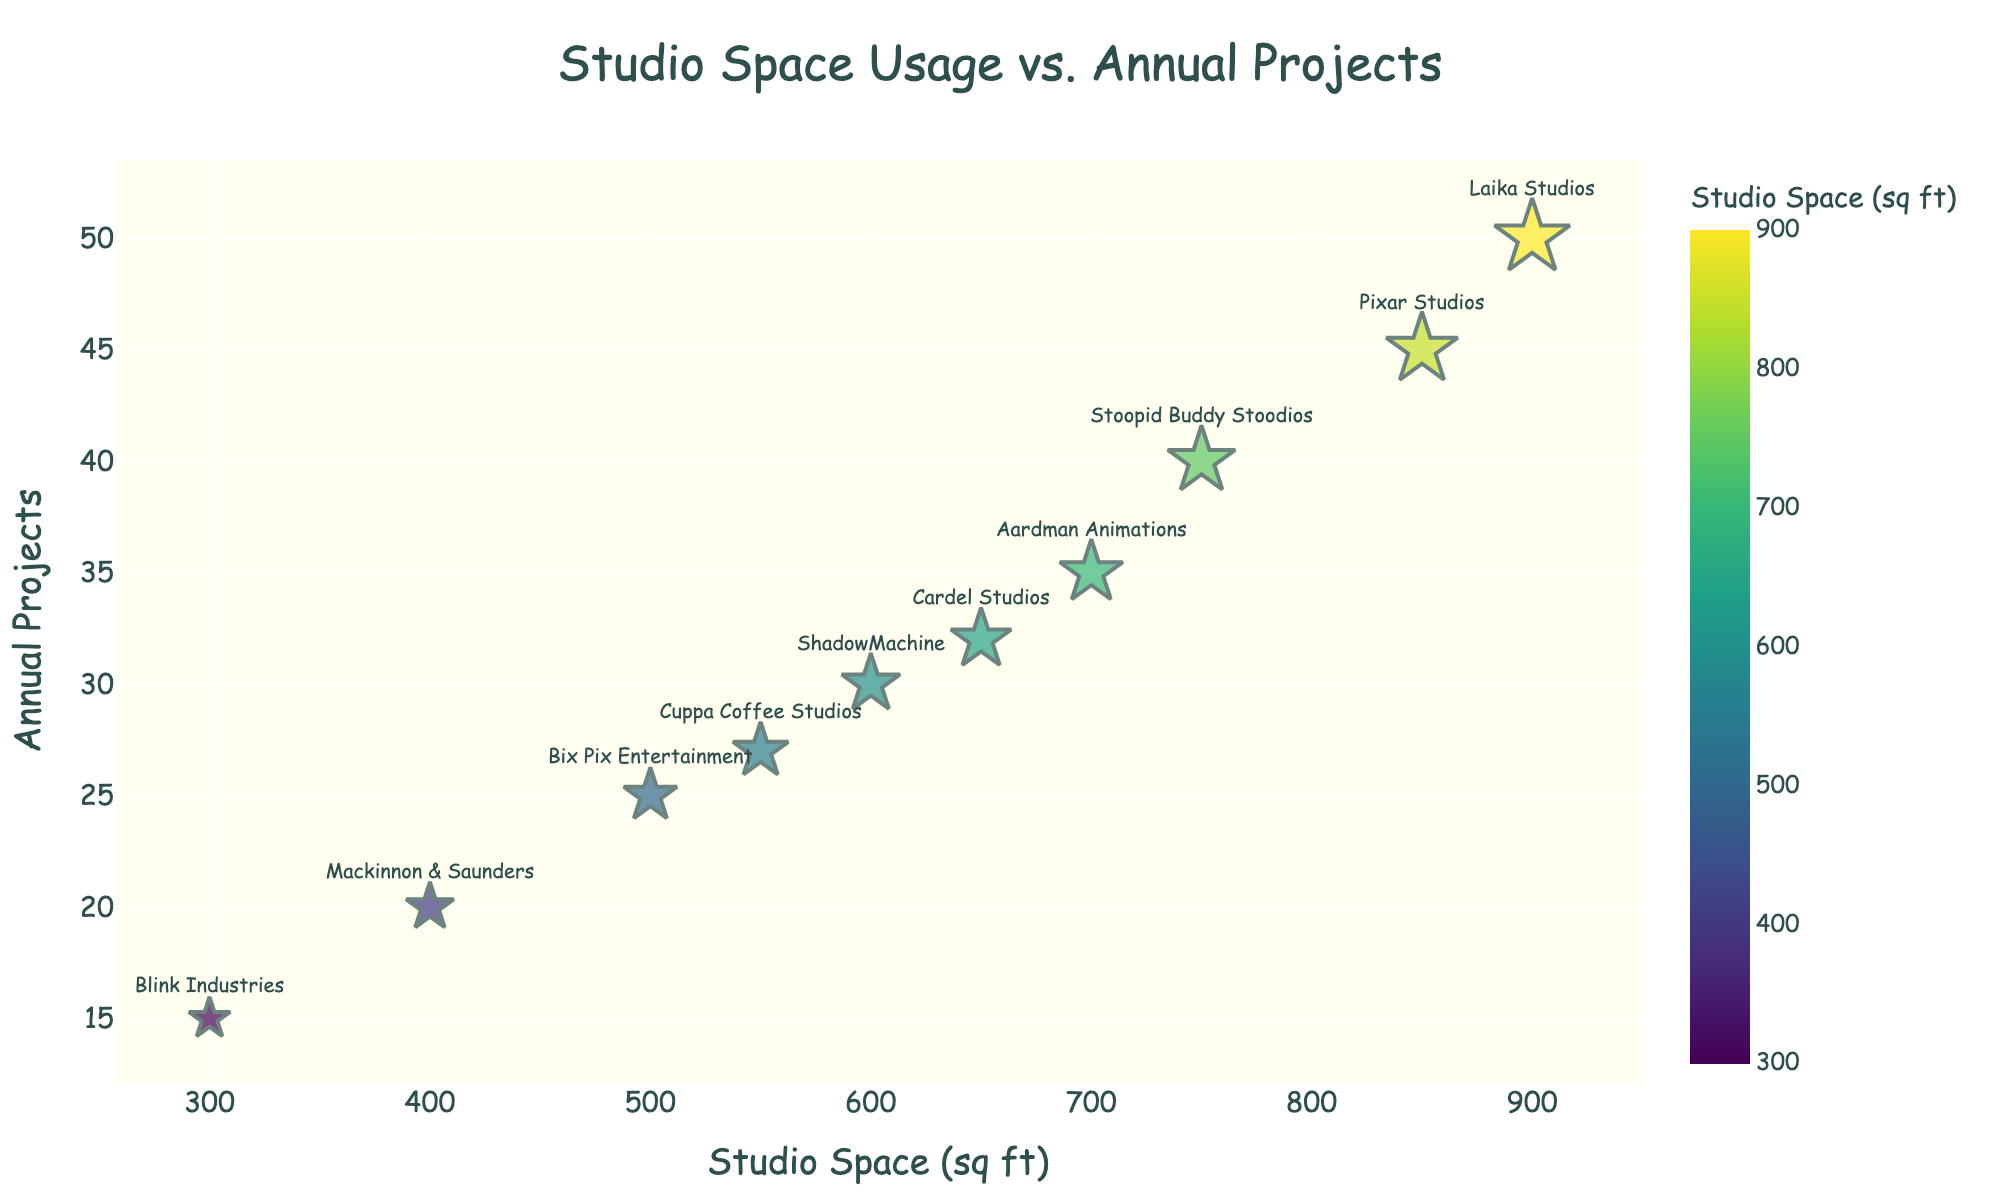What's the title of the plot? The title of the plot is positioned at the top center and is formatted in Comic Sans MS font with a size of 24. The title clearly reads "Studio Space Usage vs. Annual Projects."
Answer: Studio Space Usage vs. Annual Projects What does the x-axis represent? The x-axis is labeled "Studio Space (sq ft)," where "sq ft" stands for square feet, indicating the amount of studio space used by each studio.
Answer: Studio Space (sq ft) How many studios are represented in the plot? Each data point on the plot represents a studio, and from the data, there are 10 studios in total.
Answer: 10 Which studio has the highest number of projects annually? To determine the studio with the highest number of projects annually, look for the point that is placed highest on the y-axis. Laika Studios is the highest with 50 projects.
Answer: Laika Studios Which studio has the smallest space usage? To find the studio with the smallest space usage, look at the point farthest to the left on the x-axis. Blink Industries has the smallest space usage at 300 square feet.
Answer: Blink Industries Which studio handles more projects annually, Cuppa Coffee Studios or Stoopid Buddy Stoodios? By locating both studios on the plot and comparing their y-values, Cuppa Coffee Studios handles 27 projects annually, whereas Stoopid Buddy Stoodios handles 40 projects annually. Therefore, Stoopid Buddy Stoodios handles more projects.
Answer: Stoopid Buddy Stoodios What is the difference in space usage between Pixar Studios and Mackinnon & Saunders? Pixar Studios has a space usage of 850 square feet, and Mackinnon & Saunders has a space usage of 400 square feet. The difference is calculated as 850 - 400.
Answer: 450 sq ft What's the average number of projects handled by studios with more than 700 square feet? Identify studios with more than 700 square feet: Pixar Studios (45), Laika Studios (50), and Aardman Animations (35). Sum up their projects: 45 + 50 + 35 = 130. There are 3 such studios, so the average is 130 / 3.
Answer: 43.33 Is there a visible trend between space usage and the number of projects handled annually? Observing the scatter plot, studios with larger space usage generally tend to handle more projects, although there are some exceptions. This indicates a positive correlation.
Answer: Positive correlation Which studio is closest to the average space usage of all studios? Calculate the average space usage: (850 + 900 + 700 + 600 + 750 + 500 + 550 + 400 + 300 + 650) / 10 = 6200 / 10 = 620 sq ft. The studio closest to 620 sq ft is ShadowMachine with 600 sq ft.
Answer: ShadowMachine 